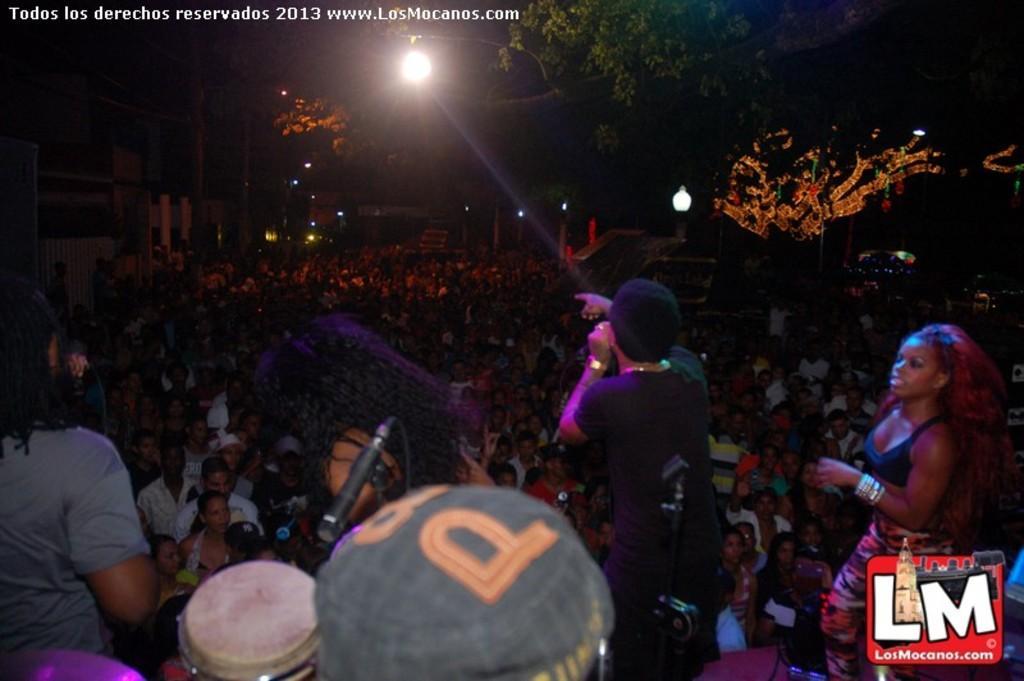Describe this image in one or two sentences. In this image it looks like it is a music concert. At the bottom there are few people standing on the stage. In the middle there is a person who is speaking in the mic. In front of them there are so many spectators. At the top there is the light. On the right side there are trees. 